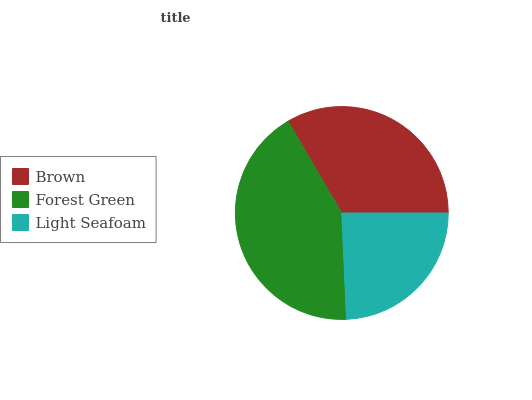Is Light Seafoam the minimum?
Answer yes or no. Yes. Is Forest Green the maximum?
Answer yes or no. Yes. Is Forest Green the minimum?
Answer yes or no. No. Is Light Seafoam the maximum?
Answer yes or no. No. Is Forest Green greater than Light Seafoam?
Answer yes or no. Yes. Is Light Seafoam less than Forest Green?
Answer yes or no. Yes. Is Light Seafoam greater than Forest Green?
Answer yes or no. No. Is Forest Green less than Light Seafoam?
Answer yes or no. No. Is Brown the high median?
Answer yes or no. Yes. Is Brown the low median?
Answer yes or no. Yes. Is Light Seafoam the high median?
Answer yes or no. No. Is Forest Green the low median?
Answer yes or no. No. 